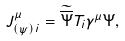Convert formula to latex. <formula><loc_0><loc_0><loc_500><loc_500>J ^ { \mu } _ { ( \psi ) \, i } = \widetilde { \overline { \Psi } } T _ { i } \gamma ^ { \mu } \Psi ,</formula> 